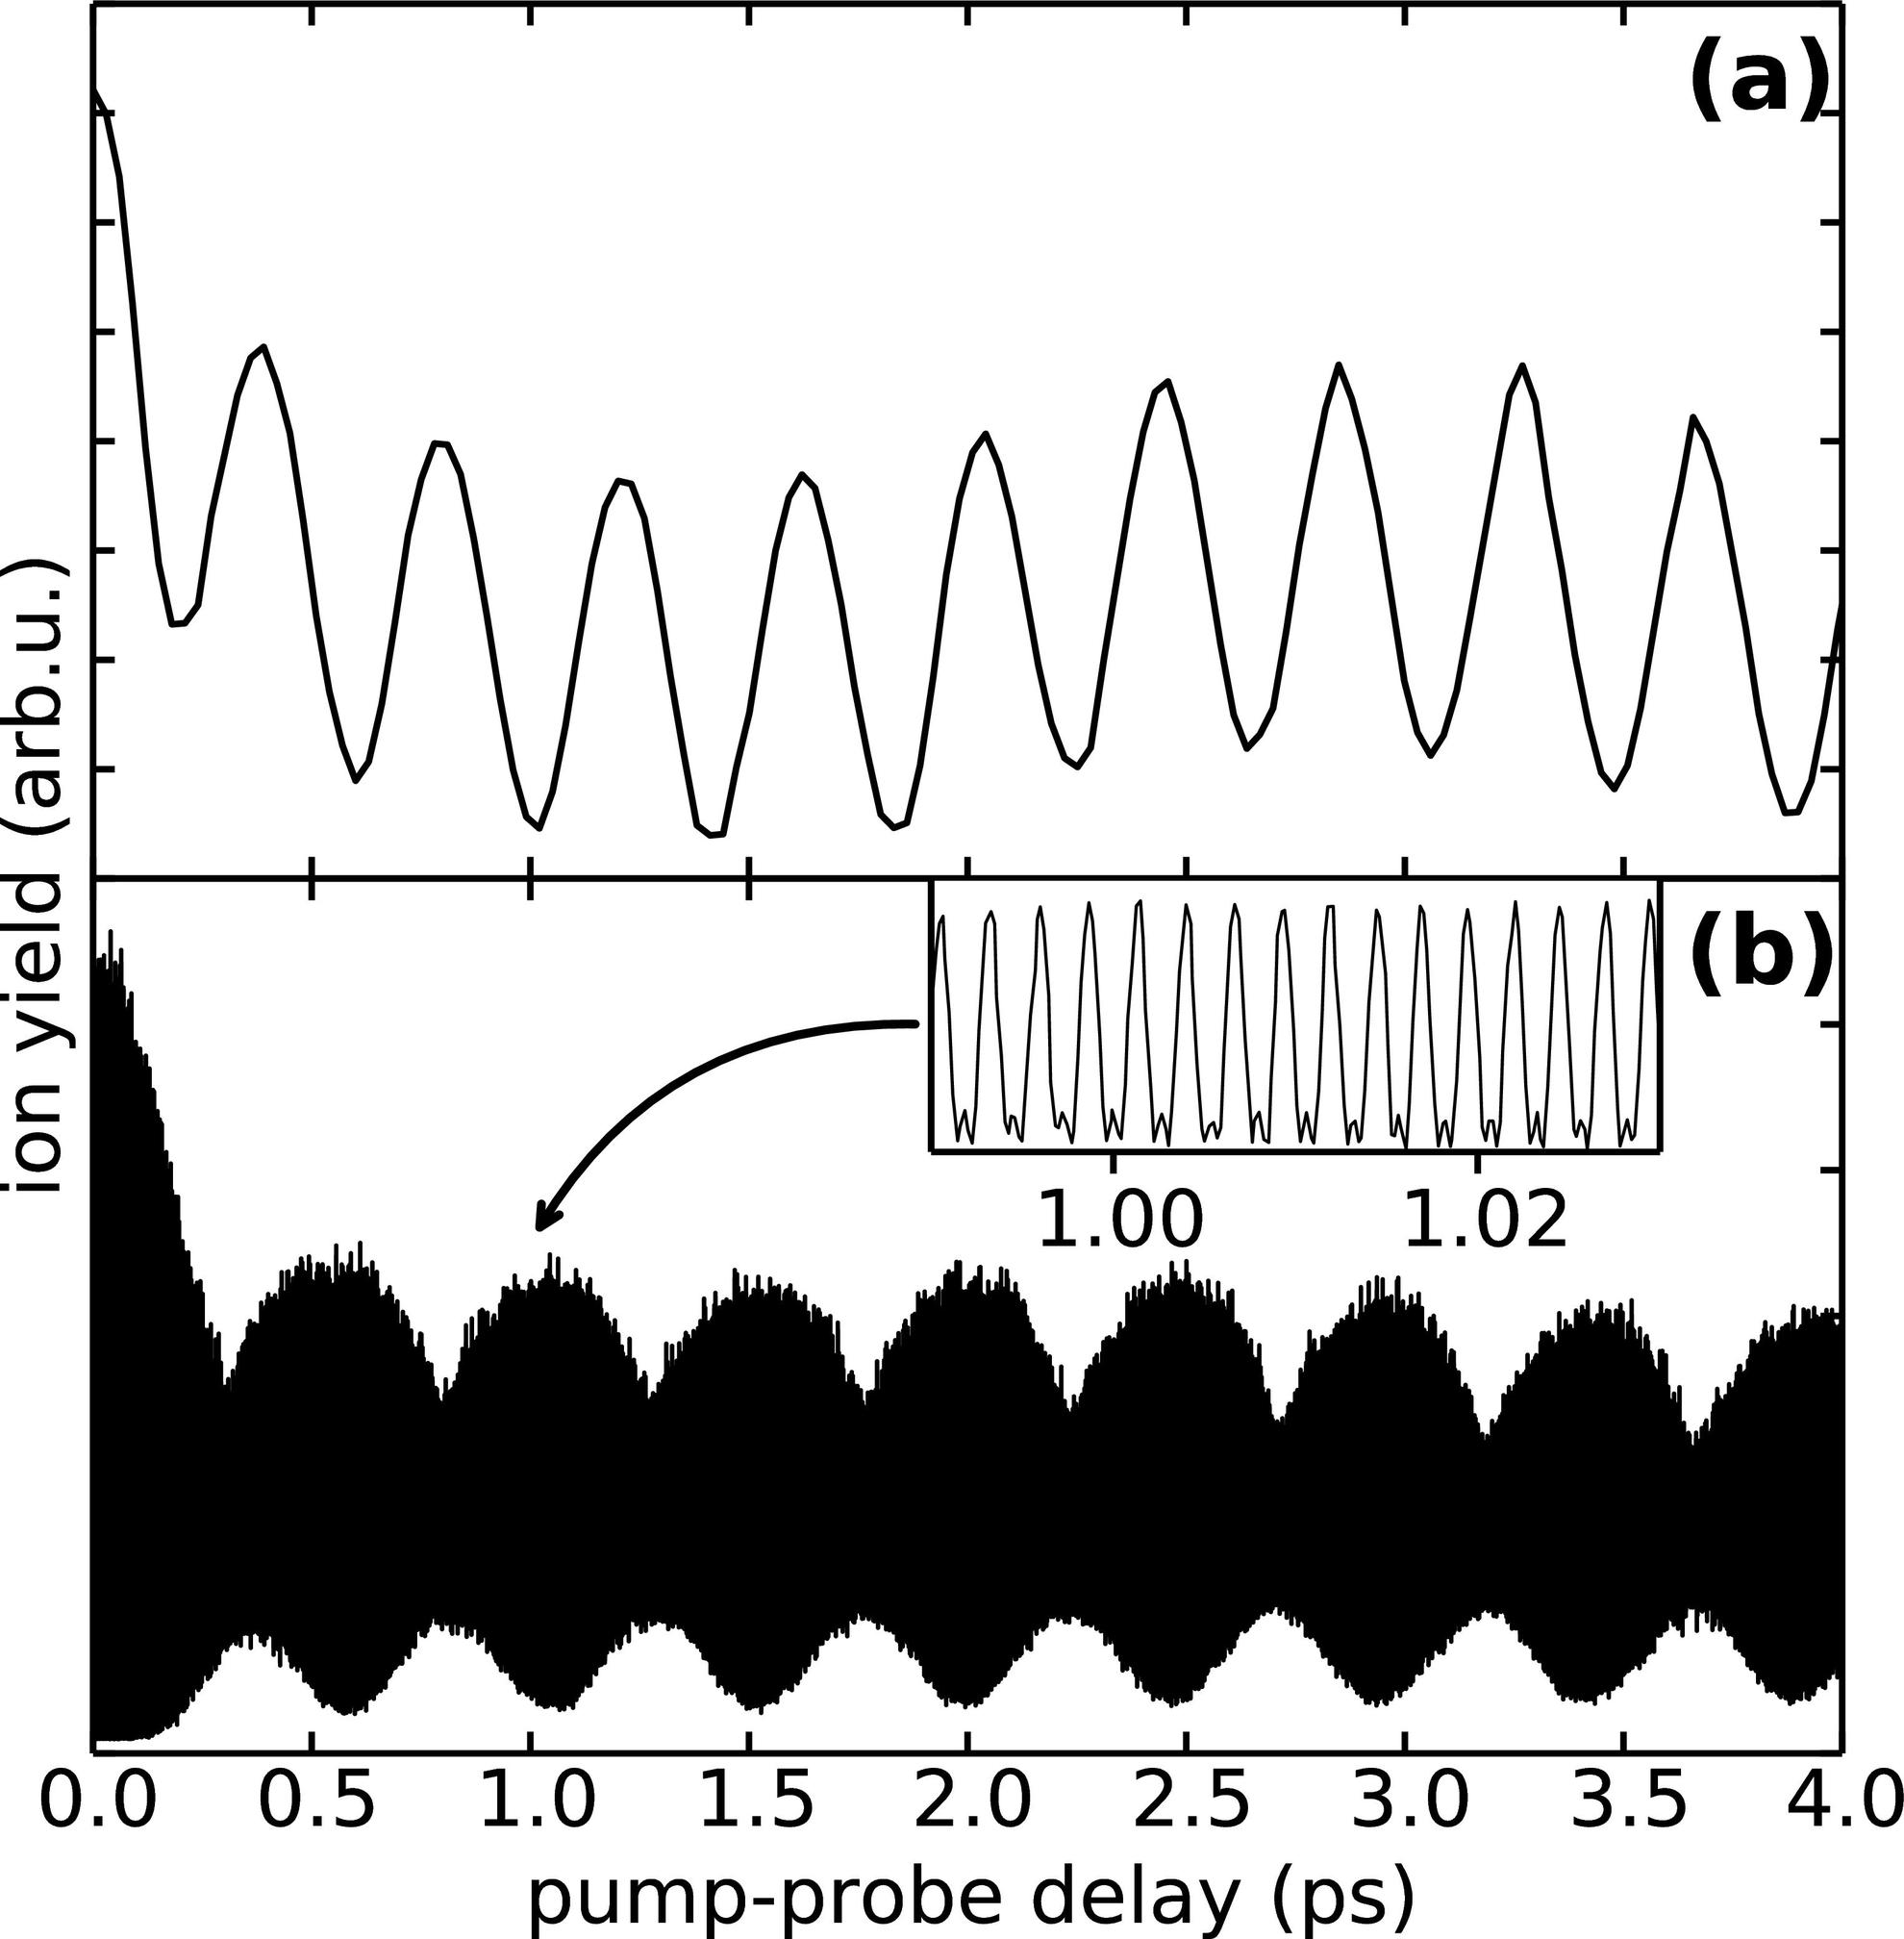The main graph in panel (b) appears to show some distortion in amplitude over time. What could cause this? The variations in amplitude noticeable in panel (b) could result from several factors including experimental noise, instability in the setup, or intrinsic changes in the system being probed, such as thermal effects or interaction with varying field strengths. Distortions can alter the apparent dynamics observed, hence careful calibration and control of experimental conditions are essential for accurate data interpretation. 